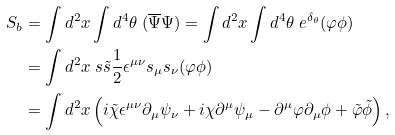Convert formula to latex. <formula><loc_0><loc_0><loc_500><loc_500>S _ { b } & = \int d ^ { 2 } x \int d ^ { 4 } \theta \ ( \overline { \Psi } \Psi ) = \int d ^ { 2 } x \int d ^ { 4 } \theta \ e ^ { \delta _ { \theta } } ( \varphi \phi ) \\ & = \int d ^ { 2 } x \ s \tilde { s } \frac { 1 } { 2 } \epsilon ^ { \mu \nu } s _ { \mu } s _ { \nu } ( \varphi \phi ) \\ & = \int d ^ { 2 } x \left ( i \tilde { \chi } \epsilon ^ { \mu \nu } \partial _ { \mu } \psi _ { \nu } + i \chi \partial ^ { \mu } \psi _ { \mu } - \partial ^ { \mu } \varphi \partial _ { \mu } \phi + \tilde { \varphi } \tilde { \phi } \right ) ,</formula> 